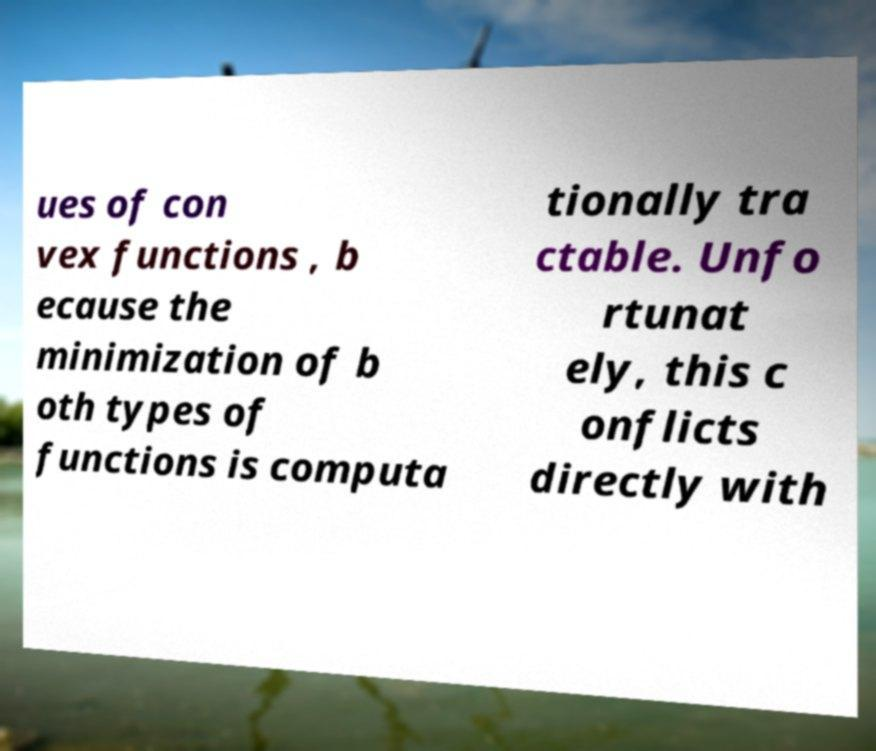Please read and relay the text visible in this image. What does it say? ues of con vex functions , b ecause the minimization of b oth types of functions is computa tionally tra ctable. Unfo rtunat ely, this c onflicts directly with 